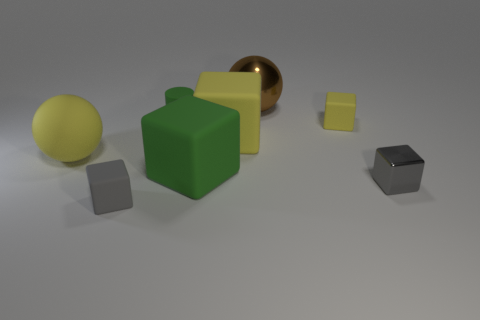Subtract all gray blocks. How many blocks are left? 3 Add 2 gray cylinders. How many objects exist? 10 Subtract all gray cubes. How many cubes are left? 3 Subtract 4 blocks. How many blocks are left? 1 Subtract all gray spheres. How many yellow cubes are left? 2 Subtract all cyan objects. Subtract all green rubber blocks. How many objects are left? 7 Add 1 tiny rubber cubes. How many tiny rubber cubes are left? 3 Add 5 green things. How many green things exist? 7 Subtract 1 yellow blocks. How many objects are left? 7 Subtract all cylinders. How many objects are left? 7 